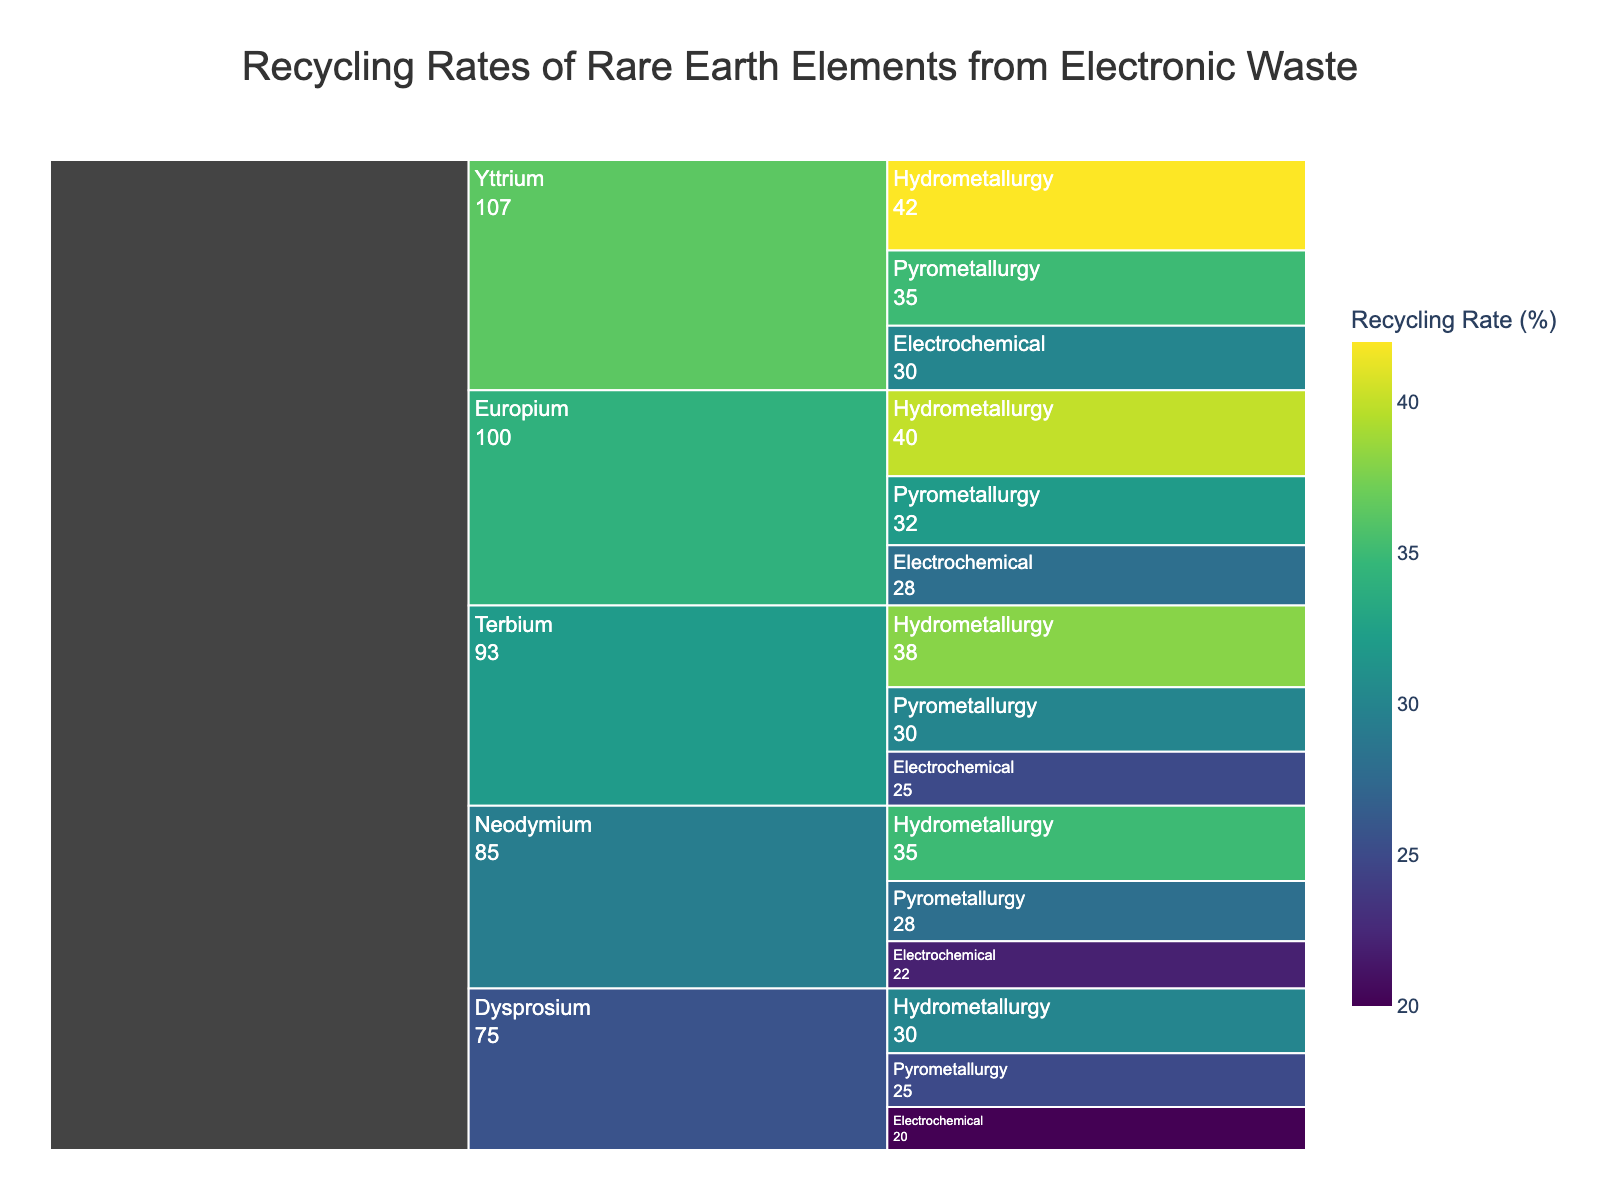What's the title of the chart? The title is prominently displayed at the top of the chart in a large font size. It summarizes the entire visual.
Answer: Recycling Rates of Rare Earth Elements from Electronic Waste Which recycling method has the highest rate for Europium? To answer this, look for the sections under Europium and compare the recycling rates for hydrometallurgy, pyrometallurgy, and electrochemical methods.
Answer: Hydrometallurgy What is the range of recycling rates for Neodymium across all methods? Identify the recycling rates for Neodymium across hydrometallurgy, pyrometallurgy, and electrochemical methods. Then, calculate the range by subtracting the lowest rate from the highest rate.
Answer: 35 - 22 = 13 Which element has the overall highest recycling rate and with which method? Examine the recycling rates for all elements and their methods, and identify the one with the highest rate.
Answer: Yttrium, Hydrometallurgy Compare the recycling rate of Terbium via pyrometallurgy with Dysprosium via electrochemical methods. Which one is higher? Find the recycling rates for Terbium using pyrometallurgy and Dysprosium using electrochemical methods, and compare these values directly.
Answer: Terbium (30% vs. 20%) What is the average recycling rate for Yttrium across all methods? Sum up the recycling rates for Yttrium for hydrometallurgy, pyrometallurgy, and electrochemical methods and divide by the number of methods (which is 3).
Answer: (42 + 35 + 30) / 3 = 35.67 How does the recycling rate of Dysprosium via hydrometallurgy compare to that of Europium via electrochemical methods? Find and compare the recycling rates of Dysprosium using hydrometallurgy and Europium using electrochemical methods.
Answer: Dysprosium (30%) is higher than Europium (28%) What’s the total combined recycling rate for Neodymium across all methods? Add the recycling rates for Neodymium using hydrometallurgy, pyrometallurgy, and electrochemical methods.
Answer: 35 + 28 + 22 = 85 Which element has the lowest recycling rate and with which method? Scan through the recycling rates for all elements and identify the lowest rate and the associated method.
Answer: Dysprosium, Electrochemical (20%) How much higher is the recycling rate of Yttrium via pyrometallurgy compared to Neodymium via the same method? Subtract the recycling rate for Neodymium using pyrometallurgy from the rate for Yttrium using pyrometallurgy.
Answer: 35 - 28 = 7 